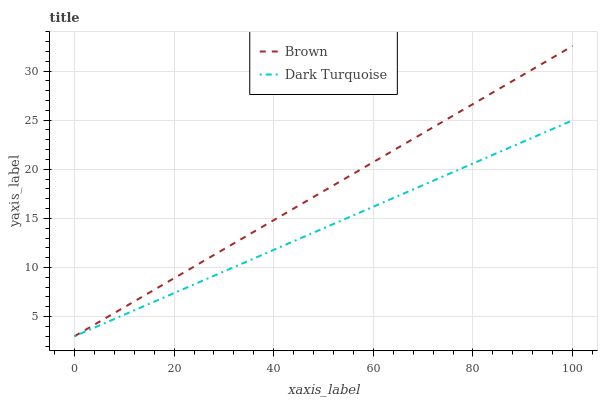Does Dark Turquoise have the maximum area under the curve?
Answer yes or no. No. Is Dark Turquoise the smoothest?
Answer yes or no. No. Does Dark Turquoise have the highest value?
Answer yes or no. No. 